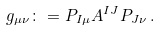Convert formula to latex. <formula><loc_0><loc_0><loc_500><loc_500>g _ { \mu \nu } \colon = P _ { I \mu } A ^ { I J } P _ { J \nu } \, .</formula> 